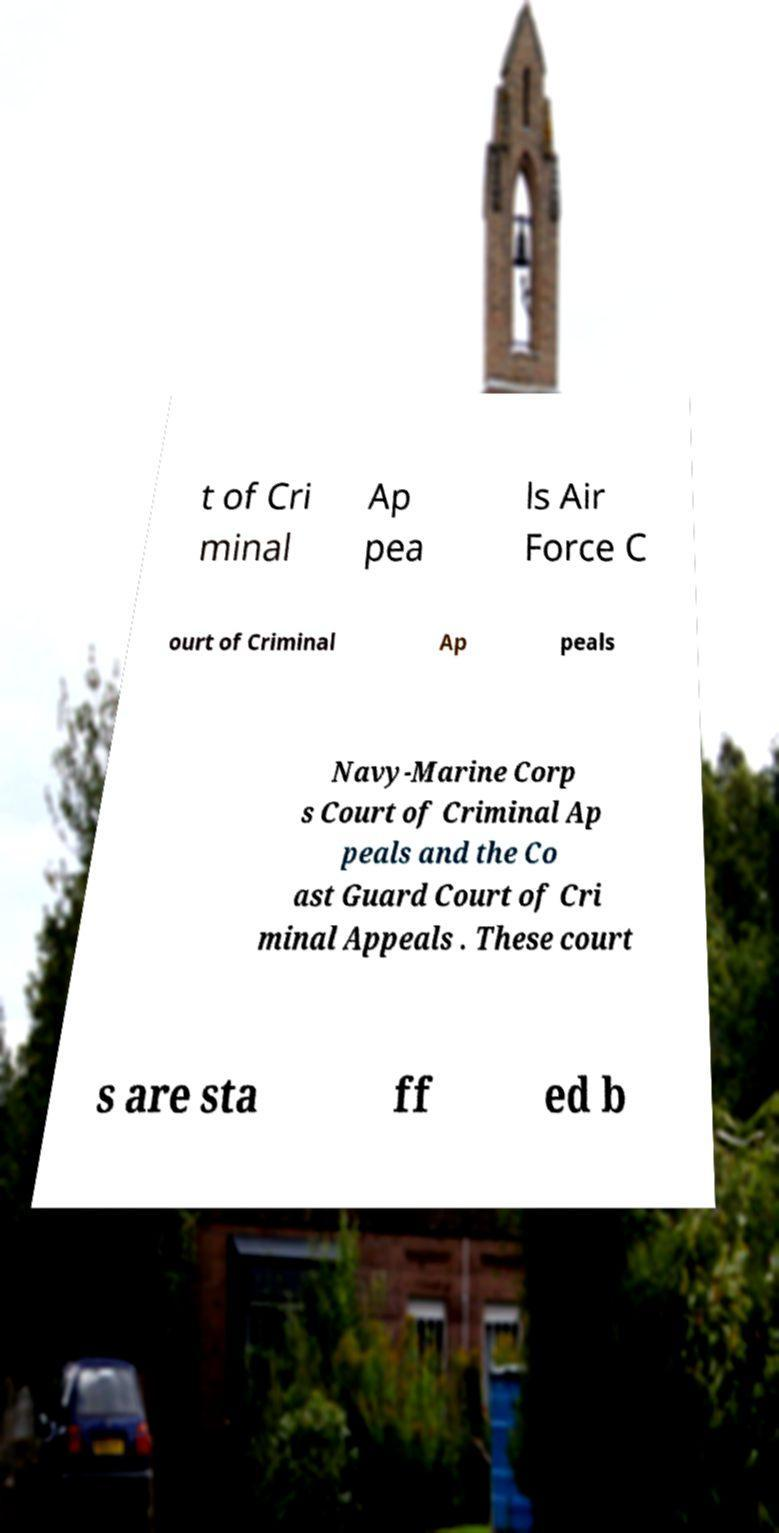There's text embedded in this image that I need extracted. Can you transcribe it verbatim? t of Cri minal Ap pea ls Air Force C ourt of Criminal Ap peals Navy-Marine Corp s Court of Criminal Ap peals and the Co ast Guard Court of Cri minal Appeals . These court s are sta ff ed b 